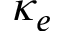<formula> <loc_0><loc_0><loc_500><loc_500>\kappa _ { e }</formula> 